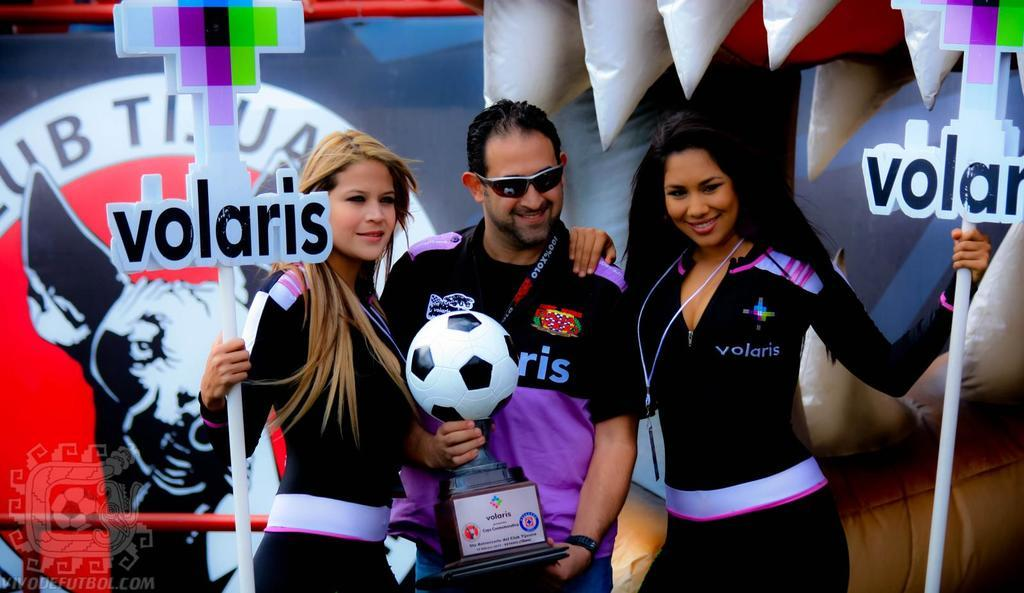<image>
Relay a brief, clear account of the picture shown. A man and woman standing together with a word volaris on outfits. 